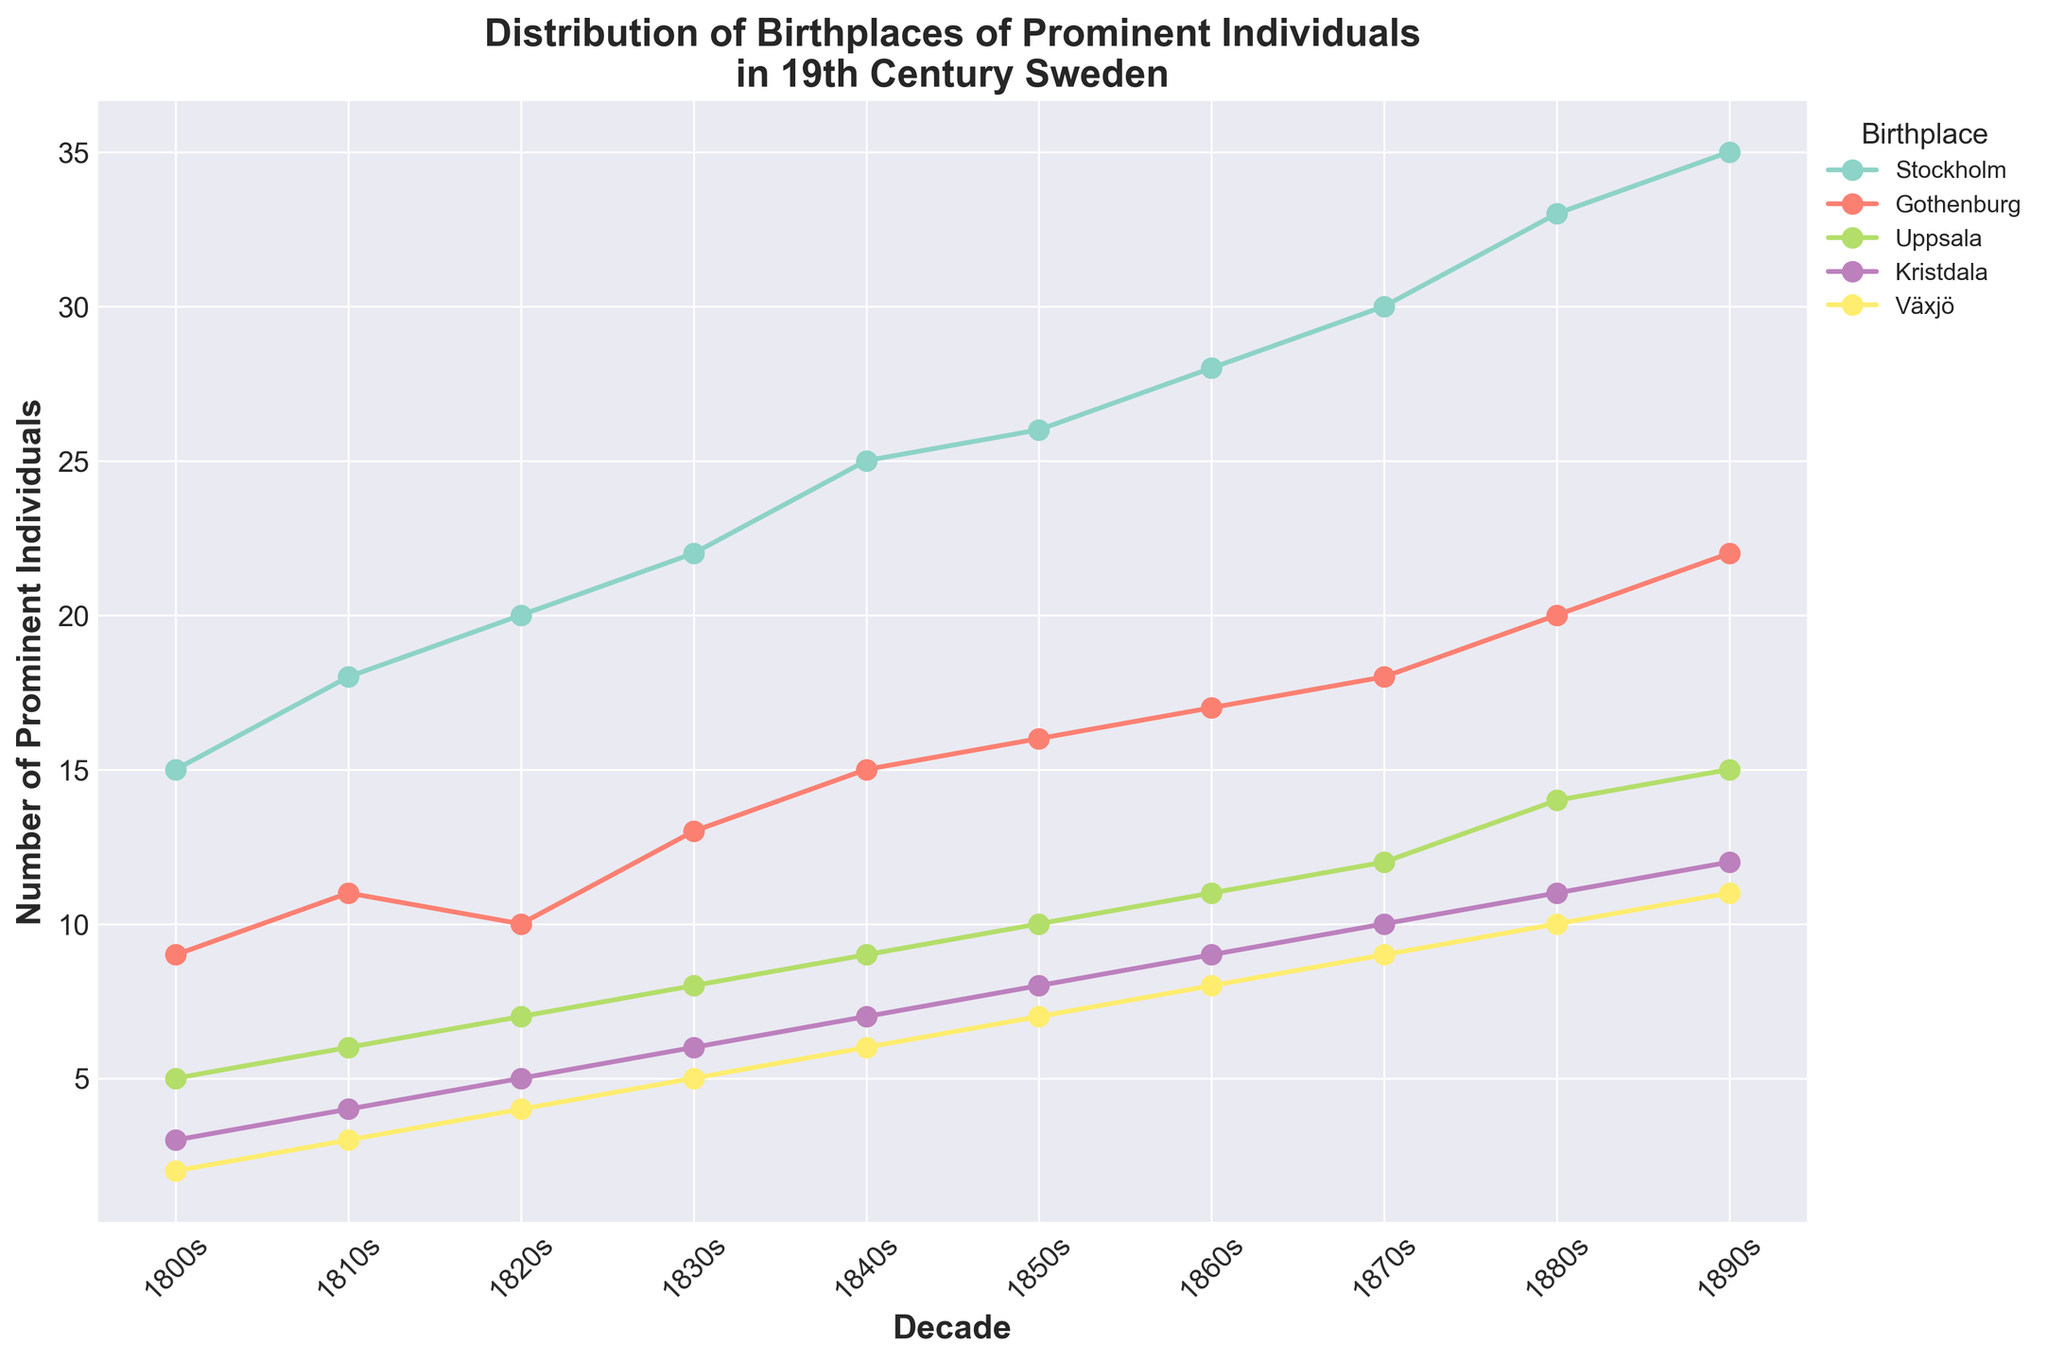What is the title of the figure? The title is displayed at the top of the figure and reads "Distribution of Birthplaces of Prominent Individuals in 19th Century Sweden."
Answer: Distribution of Birthplaces of Prominent Individuals in 19th Century Sweden Which birthplace had the most prominent individuals in the 1800s? The data points for each birthplace are plotted on the graph. By checking the 1800s data points, Stockholm has the highest number of prominent individuals at 15.
Answer: Stockholm How did the number of prominent individuals from Kristdala change from the 1860s to the 1890s? To determine the change, subtract the number in the 1860s (9) from the number in the 1890s (12). This yields an increase of 3 individuals.
Answer: Increased by 3 Which decade had the highest number of prominent individuals from Gothenburg? Examine the plot where Gothenburg is indicated by a specific color line. The decade with the highest data point corresponds to the 1890s with 22 individuals.
Answer: 1890s Compared to Växjö, how many more prominent individuals were from Stockholm in the 1870s? Identify the values for Växjö (9) and Stockholm (30) in the 1870s, then subtract Växjö's number from Stockholm's number (30 - 9). This gives a difference of 21.
Answer: 21 more What is the general trend for the number of prominent individuals from Uppsala over the decades? Observe the line plot for Uppsala across all decades. The number of prominent individuals shows a generally increasing trend.
Answer: Increasing Which birthplace showed a continuous increase in the number of prominent individuals from the 1800s to the 1890s? By examining all the plotted lines, Stockholm shows a continuous increase over all decades without any decline.
Answer: Stockholm In the 1850s, which birthplace had fewer prominent individuals than Kristdala but more than Växjö? Check the data points for the 1850s; Kristdala has 8, Växjö has 7. Bold chooses Gothenburg which has 16, and Uppsala with 10, which exists between.
Answer: None How many prominent individuals were born in Uppsala in the 1830s compared to the 1880s? Find the values for Uppsala in the 1830s (8) and the 1880s (14), then calculate the difference (14 - 8). The difference is 6.
Answer: 6 more What is the relationship between Kristdala and Växjö in terms of prominent individuals born in the 1810s? Compare the values directly; in the 1810s, Kristdala had 4 prominent individuals while Växjö had 3. Kristdala had 1 more than Växjö.
Answer: Kristdala had 1 more 